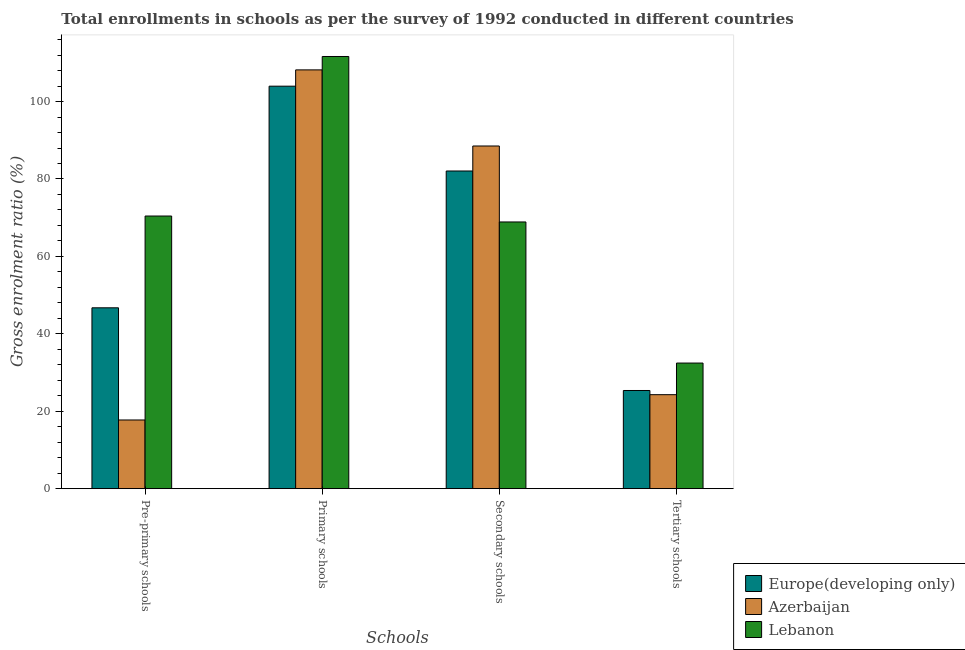How many different coloured bars are there?
Your answer should be very brief. 3. How many bars are there on the 3rd tick from the left?
Provide a short and direct response. 3. How many bars are there on the 2nd tick from the right?
Offer a terse response. 3. What is the label of the 4th group of bars from the left?
Your answer should be compact. Tertiary schools. What is the gross enrolment ratio in primary schools in Europe(developing only)?
Offer a terse response. 103.97. Across all countries, what is the maximum gross enrolment ratio in tertiary schools?
Offer a terse response. 32.45. Across all countries, what is the minimum gross enrolment ratio in tertiary schools?
Provide a short and direct response. 24.28. In which country was the gross enrolment ratio in tertiary schools maximum?
Provide a succinct answer. Lebanon. In which country was the gross enrolment ratio in primary schools minimum?
Offer a terse response. Europe(developing only). What is the total gross enrolment ratio in tertiary schools in the graph?
Make the answer very short. 82.1. What is the difference between the gross enrolment ratio in primary schools in Europe(developing only) and that in Azerbaijan?
Provide a short and direct response. -4.21. What is the difference between the gross enrolment ratio in secondary schools in Azerbaijan and the gross enrolment ratio in tertiary schools in Europe(developing only)?
Offer a very short reply. 63.16. What is the average gross enrolment ratio in secondary schools per country?
Make the answer very short. 79.83. What is the difference between the gross enrolment ratio in secondary schools and gross enrolment ratio in tertiary schools in Lebanon?
Offer a terse response. 36.44. In how many countries, is the gross enrolment ratio in tertiary schools greater than 112 %?
Give a very brief answer. 0. What is the ratio of the gross enrolment ratio in primary schools in Europe(developing only) to that in Azerbaijan?
Offer a terse response. 0.96. Is the gross enrolment ratio in primary schools in Lebanon less than that in Azerbaijan?
Ensure brevity in your answer.  No. What is the difference between the highest and the second highest gross enrolment ratio in secondary schools?
Offer a very short reply. 6.46. What is the difference between the highest and the lowest gross enrolment ratio in primary schools?
Ensure brevity in your answer.  7.67. In how many countries, is the gross enrolment ratio in tertiary schools greater than the average gross enrolment ratio in tertiary schools taken over all countries?
Give a very brief answer. 1. What does the 3rd bar from the left in Pre-primary schools represents?
Ensure brevity in your answer.  Lebanon. What does the 3rd bar from the right in Tertiary schools represents?
Provide a short and direct response. Europe(developing only). How many countries are there in the graph?
Your answer should be compact. 3. What is the difference between two consecutive major ticks on the Y-axis?
Provide a short and direct response. 20. Does the graph contain any zero values?
Give a very brief answer. No. Does the graph contain grids?
Provide a short and direct response. No. Where does the legend appear in the graph?
Provide a short and direct response. Bottom right. What is the title of the graph?
Your answer should be very brief. Total enrollments in schools as per the survey of 1992 conducted in different countries. What is the label or title of the X-axis?
Keep it short and to the point. Schools. What is the label or title of the Y-axis?
Make the answer very short. Gross enrolment ratio (%). What is the Gross enrolment ratio (%) of Europe(developing only) in Pre-primary schools?
Offer a very short reply. 46.72. What is the Gross enrolment ratio (%) in Azerbaijan in Pre-primary schools?
Provide a succinct answer. 17.75. What is the Gross enrolment ratio (%) in Lebanon in Pre-primary schools?
Give a very brief answer. 70.43. What is the Gross enrolment ratio (%) in Europe(developing only) in Primary schools?
Your answer should be very brief. 103.97. What is the Gross enrolment ratio (%) of Azerbaijan in Primary schools?
Give a very brief answer. 108.18. What is the Gross enrolment ratio (%) of Lebanon in Primary schools?
Keep it short and to the point. 111.64. What is the Gross enrolment ratio (%) in Europe(developing only) in Secondary schools?
Keep it short and to the point. 82.06. What is the Gross enrolment ratio (%) in Azerbaijan in Secondary schools?
Provide a short and direct response. 88.52. What is the Gross enrolment ratio (%) in Lebanon in Secondary schools?
Offer a very short reply. 68.9. What is the Gross enrolment ratio (%) of Europe(developing only) in Tertiary schools?
Give a very brief answer. 25.36. What is the Gross enrolment ratio (%) of Azerbaijan in Tertiary schools?
Ensure brevity in your answer.  24.28. What is the Gross enrolment ratio (%) in Lebanon in Tertiary schools?
Your response must be concise. 32.45. Across all Schools, what is the maximum Gross enrolment ratio (%) in Europe(developing only)?
Provide a succinct answer. 103.97. Across all Schools, what is the maximum Gross enrolment ratio (%) of Azerbaijan?
Provide a short and direct response. 108.18. Across all Schools, what is the maximum Gross enrolment ratio (%) of Lebanon?
Your answer should be very brief. 111.64. Across all Schools, what is the minimum Gross enrolment ratio (%) in Europe(developing only)?
Provide a short and direct response. 25.36. Across all Schools, what is the minimum Gross enrolment ratio (%) in Azerbaijan?
Your answer should be very brief. 17.75. Across all Schools, what is the minimum Gross enrolment ratio (%) in Lebanon?
Keep it short and to the point. 32.45. What is the total Gross enrolment ratio (%) of Europe(developing only) in the graph?
Make the answer very short. 258.12. What is the total Gross enrolment ratio (%) in Azerbaijan in the graph?
Your answer should be very brief. 238.73. What is the total Gross enrolment ratio (%) of Lebanon in the graph?
Your answer should be compact. 283.42. What is the difference between the Gross enrolment ratio (%) of Europe(developing only) in Pre-primary schools and that in Primary schools?
Your answer should be very brief. -57.25. What is the difference between the Gross enrolment ratio (%) in Azerbaijan in Pre-primary schools and that in Primary schools?
Provide a succinct answer. -90.44. What is the difference between the Gross enrolment ratio (%) of Lebanon in Pre-primary schools and that in Primary schools?
Offer a very short reply. -41.21. What is the difference between the Gross enrolment ratio (%) of Europe(developing only) in Pre-primary schools and that in Secondary schools?
Offer a terse response. -35.34. What is the difference between the Gross enrolment ratio (%) of Azerbaijan in Pre-primary schools and that in Secondary schools?
Give a very brief answer. -70.77. What is the difference between the Gross enrolment ratio (%) in Lebanon in Pre-primary schools and that in Secondary schools?
Offer a very short reply. 1.53. What is the difference between the Gross enrolment ratio (%) of Europe(developing only) in Pre-primary schools and that in Tertiary schools?
Make the answer very short. 21.36. What is the difference between the Gross enrolment ratio (%) in Azerbaijan in Pre-primary schools and that in Tertiary schools?
Your answer should be very brief. -6.54. What is the difference between the Gross enrolment ratio (%) of Lebanon in Pre-primary schools and that in Tertiary schools?
Offer a terse response. 37.98. What is the difference between the Gross enrolment ratio (%) in Europe(developing only) in Primary schools and that in Secondary schools?
Give a very brief answer. 21.91. What is the difference between the Gross enrolment ratio (%) of Azerbaijan in Primary schools and that in Secondary schools?
Your response must be concise. 19.66. What is the difference between the Gross enrolment ratio (%) of Lebanon in Primary schools and that in Secondary schools?
Your answer should be compact. 42.75. What is the difference between the Gross enrolment ratio (%) in Europe(developing only) in Primary schools and that in Tertiary schools?
Give a very brief answer. 78.61. What is the difference between the Gross enrolment ratio (%) of Azerbaijan in Primary schools and that in Tertiary schools?
Keep it short and to the point. 83.9. What is the difference between the Gross enrolment ratio (%) of Lebanon in Primary schools and that in Tertiary schools?
Ensure brevity in your answer.  79.19. What is the difference between the Gross enrolment ratio (%) of Europe(developing only) in Secondary schools and that in Tertiary schools?
Your response must be concise. 56.7. What is the difference between the Gross enrolment ratio (%) of Azerbaijan in Secondary schools and that in Tertiary schools?
Provide a succinct answer. 64.24. What is the difference between the Gross enrolment ratio (%) in Lebanon in Secondary schools and that in Tertiary schools?
Give a very brief answer. 36.44. What is the difference between the Gross enrolment ratio (%) in Europe(developing only) in Pre-primary schools and the Gross enrolment ratio (%) in Azerbaijan in Primary schools?
Provide a short and direct response. -61.46. What is the difference between the Gross enrolment ratio (%) in Europe(developing only) in Pre-primary schools and the Gross enrolment ratio (%) in Lebanon in Primary schools?
Offer a very short reply. -64.92. What is the difference between the Gross enrolment ratio (%) of Azerbaijan in Pre-primary schools and the Gross enrolment ratio (%) of Lebanon in Primary schools?
Keep it short and to the point. -93.9. What is the difference between the Gross enrolment ratio (%) of Europe(developing only) in Pre-primary schools and the Gross enrolment ratio (%) of Azerbaijan in Secondary schools?
Keep it short and to the point. -41.8. What is the difference between the Gross enrolment ratio (%) in Europe(developing only) in Pre-primary schools and the Gross enrolment ratio (%) in Lebanon in Secondary schools?
Provide a short and direct response. -22.17. What is the difference between the Gross enrolment ratio (%) of Azerbaijan in Pre-primary schools and the Gross enrolment ratio (%) of Lebanon in Secondary schools?
Make the answer very short. -51.15. What is the difference between the Gross enrolment ratio (%) in Europe(developing only) in Pre-primary schools and the Gross enrolment ratio (%) in Azerbaijan in Tertiary schools?
Provide a short and direct response. 22.44. What is the difference between the Gross enrolment ratio (%) of Europe(developing only) in Pre-primary schools and the Gross enrolment ratio (%) of Lebanon in Tertiary schools?
Your answer should be compact. 14.27. What is the difference between the Gross enrolment ratio (%) in Azerbaijan in Pre-primary schools and the Gross enrolment ratio (%) in Lebanon in Tertiary schools?
Offer a very short reply. -14.71. What is the difference between the Gross enrolment ratio (%) of Europe(developing only) in Primary schools and the Gross enrolment ratio (%) of Azerbaijan in Secondary schools?
Your answer should be very brief. 15.45. What is the difference between the Gross enrolment ratio (%) of Europe(developing only) in Primary schools and the Gross enrolment ratio (%) of Lebanon in Secondary schools?
Provide a short and direct response. 35.08. What is the difference between the Gross enrolment ratio (%) of Azerbaijan in Primary schools and the Gross enrolment ratio (%) of Lebanon in Secondary schools?
Your response must be concise. 39.29. What is the difference between the Gross enrolment ratio (%) in Europe(developing only) in Primary schools and the Gross enrolment ratio (%) in Azerbaijan in Tertiary schools?
Your answer should be compact. 79.69. What is the difference between the Gross enrolment ratio (%) in Europe(developing only) in Primary schools and the Gross enrolment ratio (%) in Lebanon in Tertiary schools?
Keep it short and to the point. 71.52. What is the difference between the Gross enrolment ratio (%) of Azerbaijan in Primary schools and the Gross enrolment ratio (%) of Lebanon in Tertiary schools?
Offer a very short reply. 75.73. What is the difference between the Gross enrolment ratio (%) in Europe(developing only) in Secondary schools and the Gross enrolment ratio (%) in Azerbaijan in Tertiary schools?
Give a very brief answer. 57.78. What is the difference between the Gross enrolment ratio (%) in Europe(developing only) in Secondary schools and the Gross enrolment ratio (%) in Lebanon in Tertiary schools?
Your response must be concise. 49.61. What is the difference between the Gross enrolment ratio (%) in Azerbaijan in Secondary schools and the Gross enrolment ratio (%) in Lebanon in Tertiary schools?
Your answer should be compact. 56.07. What is the average Gross enrolment ratio (%) of Europe(developing only) per Schools?
Offer a terse response. 64.53. What is the average Gross enrolment ratio (%) in Azerbaijan per Schools?
Your answer should be compact. 59.68. What is the average Gross enrolment ratio (%) of Lebanon per Schools?
Keep it short and to the point. 70.86. What is the difference between the Gross enrolment ratio (%) in Europe(developing only) and Gross enrolment ratio (%) in Azerbaijan in Pre-primary schools?
Offer a very short reply. 28.98. What is the difference between the Gross enrolment ratio (%) in Europe(developing only) and Gross enrolment ratio (%) in Lebanon in Pre-primary schools?
Your answer should be compact. -23.71. What is the difference between the Gross enrolment ratio (%) of Azerbaijan and Gross enrolment ratio (%) of Lebanon in Pre-primary schools?
Your response must be concise. -52.68. What is the difference between the Gross enrolment ratio (%) of Europe(developing only) and Gross enrolment ratio (%) of Azerbaijan in Primary schools?
Your response must be concise. -4.21. What is the difference between the Gross enrolment ratio (%) of Europe(developing only) and Gross enrolment ratio (%) of Lebanon in Primary schools?
Provide a succinct answer. -7.67. What is the difference between the Gross enrolment ratio (%) in Azerbaijan and Gross enrolment ratio (%) in Lebanon in Primary schools?
Offer a very short reply. -3.46. What is the difference between the Gross enrolment ratio (%) in Europe(developing only) and Gross enrolment ratio (%) in Azerbaijan in Secondary schools?
Offer a very short reply. -6.46. What is the difference between the Gross enrolment ratio (%) in Europe(developing only) and Gross enrolment ratio (%) in Lebanon in Secondary schools?
Provide a succinct answer. 13.17. What is the difference between the Gross enrolment ratio (%) of Azerbaijan and Gross enrolment ratio (%) of Lebanon in Secondary schools?
Make the answer very short. 19.62. What is the difference between the Gross enrolment ratio (%) in Europe(developing only) and Gross enrolment ratio (%) in Azerbaijan in Tertiary schools?
Keep it short and to the point. 1.08. What is the difference between the Gross enrolment ratio (%) of Europe(developing only) and Gross enrolment ratio (%) of Lebanon in Tertiary schools?
Give a very brief answer. -7.09. What is the difference between the Gross enrolment ratio (%) in Azerbaijan and Gross enrolment ratio (%) in Lebanon in Tertiary schools?
Provide a short and direct response. -8.17. What is the ratio of the Gross enrolment ratio (%) of Europe(developing only) in Pre-primary schools to that in Primary schools?
Offer a terse response. 0.45. What is the ratio of the Gross enrolment ratio (%) in Azerbaijan in Pre-primary schools to that in Primary schools?
Provide a succinct answer. 0.16. What is the ratio of the Gross enrolment ratio (%) of Lebanon in Pre-primary schools to that in Primary schools?
Ensure brevity in your answer.  0.63. What is the ratio of the Gross enrolment ratio (%) of Europe(developing only) in Pre-primary schools to that in Secondary schools?
Offer a very short reply. 0.57. What is the ratio of the Gross enrolment ratio (%) of Azerbaijan in Pre-primary schools to that in Secondary schools?
Your answer should be compact. 0.2. What is the ratio of the Gross enrolment ratio (%) in Lebanon in Pre-primary schools to that in Secondary schools?
Ensure brevity in your answer.  1.02. What is the ratio of the Gross enrolment ratio (%) of Europe(developing only) in Pre-primary schools to that in Tertiary schools?
Keep it short and to the point. 1.84. What is the ratio of the Gross enrolment ratio (%) in Azerbaijan in Pre-primary schools to that in Tertiary schools?
Your answer should be compact. 0.73. What is the ratio of the Gross enrolment ratio (%) in Lebanon in Pre-primary schools to that in Tertiary schools?
Your response must be concise. 2.17. What is the ratio of the Gross enrolment ratio (%) of Europe(developing only) in Primary schools to that in Secondary schools?
Give a very brief answer. 1.27. What is the ratio of the Gross enrolment ratio (%) of Azerbaijan in Primary schools to that in Secondary schools?
Your answer should be very brief. 1.22. What is the ratio of the Gross enrolment ratio (%) of Lebanon in Primary schools to that in Secondary schools?
Offer a terse response. 1.62. What is the ratio of the Gross enrolment ratio (%) of Europe(developing only) in Primary schools to that in Tertiary schools?
Make the answer very short. 4.1. What is the ratio of the Gross enrolment ratio (%) of Azerbaijan in Primary schools to that in Tertiary schools?
Offer a terse response. 4.46. What is the ratio of the Gross enrolment ratio (%) of Lebanon in Primary schools to that in Tertiary schools?
Your response must be concise. 3.44. What is the ratio of the Gross enrolment ratio (%) in Europe(developing only) in Secondary schools to that in Tertiary schools?
Ensure brevity in your answer.  3.24. What is the ratio of the Gross enrolment ratio (%) of Azerbaijan in Secondary schools to that in Tertiary schools?
Offer a terse response. 3.65. What is the ratio of the Gross enrolment ratio (%) of Lebanon in Secondary schools to that in Tertiary schools?
Provide a short and direct response. 2.12. What is the difference between the highest and the second highest Gross enrolment ratio (%) in Europe(developing only)?
Keep it short and to the point. 21.91. What is the difference between the highest and the second highest Gross enrolment ratio (%) of Azerbaijan?
Provide a succinct answer. 19.66. What is the difference between the highest and the second highest Gross enrolment ratio (%) of Lebanon?
Provide a succinct answer. 41.21. What is the difference between the highest and the lowest Gross enrolment ratio (%) of Europe(developing only)?
Provide a short and direct response. 78.61. What is the difference between the highest and the lowest Gross enrolment ratio (%) in Azerbaijan?
Provide a short and direct response. 90.44. What is the difference between the highest and the lowest Gross enrolment ratio (%) in Lebanon?
Ensure brevity in your answer.  79.19. 